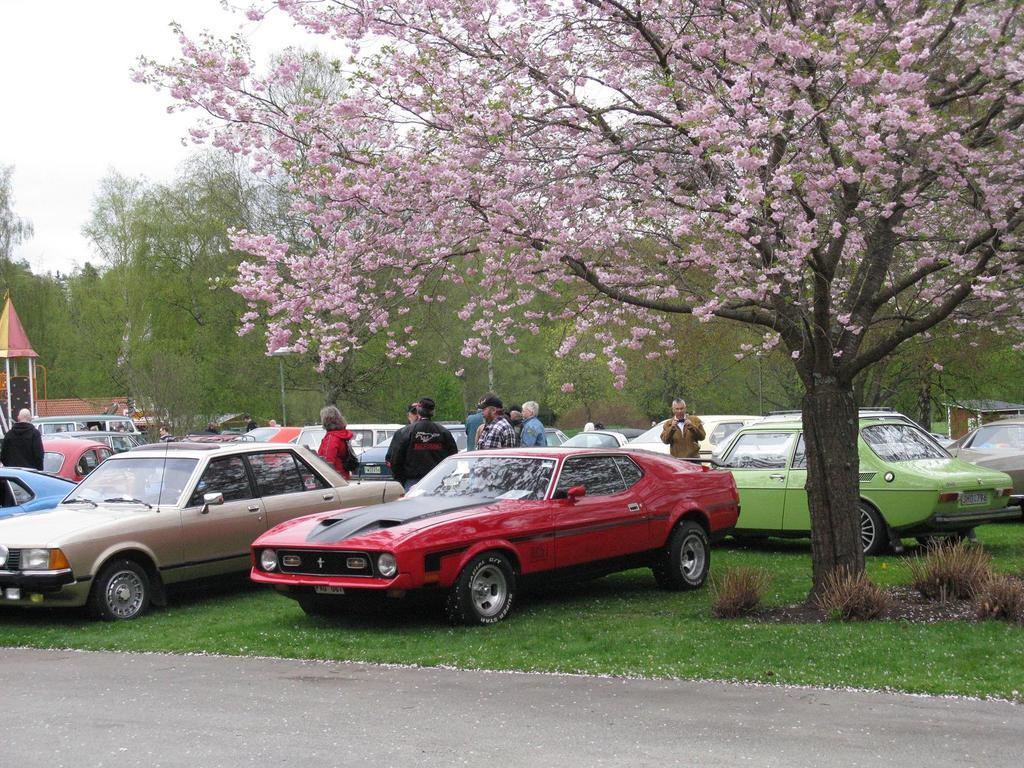What type of vegetation can be seen in the image? There are trees and plants in the image. What are the people in the image doing? The people standing in the image are not engaged in any specific activity, but their presence is noted. What is on the ground in the image? There is grass on the ground in the image. What is the condition of the sky in the image? The sky is cloudy in the image. Can you tell me how many experts are present in the image? There is no mention of any experts in the image; it features trees, cars, people, grass, plants, and a cloudy sky. What type of thread is being used by the playground equipment in the image? There is no playground equipment present in the image, so it is not possible to determine what type of thread might be used. 